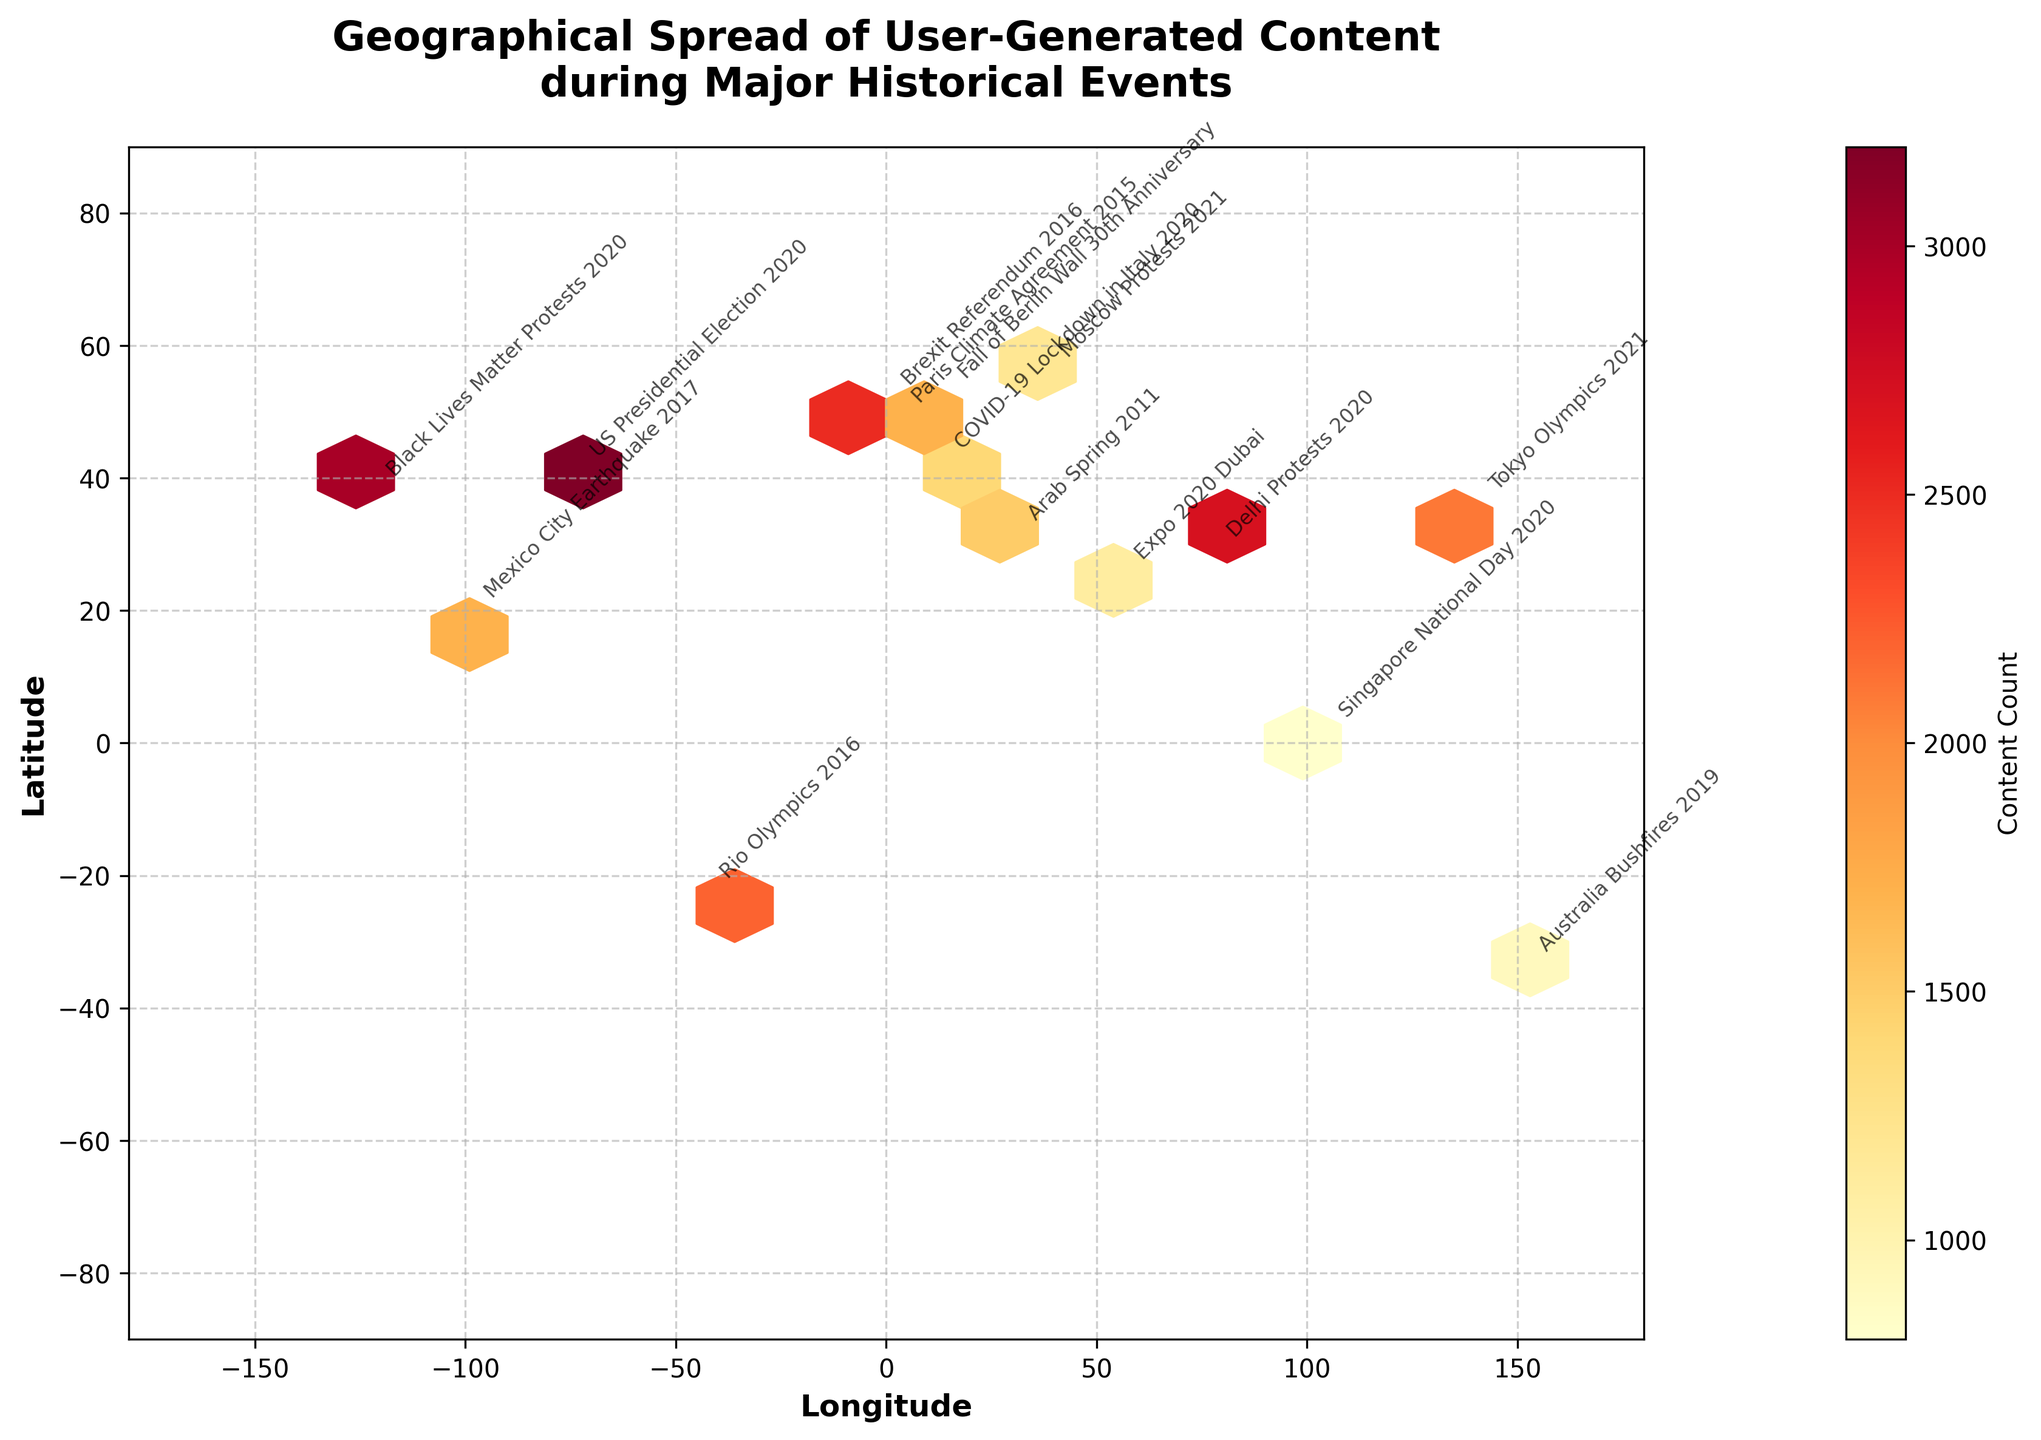What is the title of the plot? The title can be found at the top of the plot. The title is "Geographical Spread of User-Generated Content during Major Historical Events".
Answer: "Geographical Spread of User-Generated Content during Major Historical Events" How many hexagons/groups are there along the x-axis (Longitude)? The hexagons represent the geographical spread, and the extent of the x-axis is from -180 to 180 degrees, divided by the grid size of 20. Thus, there are approximately (180 - (-180)) / 20 = 18 hexagons.
Answer: Approximately 18 Which events are located near longitude 40? By locating the longitude axis and scanning around the 40-degree mark, it's observed that there are no events at longitude 40. The closest event would depend on the annotated points.
Answer: None directly at 40 Which historical event generated the highest amount of user-generated content? The highest content count is shown through color intensity in the hexbin plot. The event with the darkest hexagon and the most significant annotation would indicate the highest count. "US Presidential Election 2020" is the event with the highest count of 3200.
Answer: US Presidential Election 2020 What is the difference in content count between the "Tokyo Olympics 2021" and "Paris Climate Agreement 2015"? Tokyo Olympics 2021 corresponds to 2100 content counts while Paris Climate Agreement 2015 has 1800 content counts. The difference can be calculated as 2100 - 1800 = 300.
Answer: 300 Which event has a higher content count: "Brexit Referendum 2016" or "Black Lives Matter Protests 2020"? By comparing the annotations in the plot, "Black Lives Matter Protests 2020" has a content count of 3000, whereas "Brexit Referendum 2016" has 2500. So, the former has a higher count.
Answer: Black Lives Matter Protests 2020 What is the latitude and longitude range covered by the hexbin plot? The extent of the plot is given in the x-axis and y-axis labels, which range from -180 to 180 degrees in longitude and -90 to 90 degrees in latitude.
Answer: Longitude: -180 to 180, Latitude: -90 to 90 Which event has the lowest content count, and what is that count? The event with the lightest shade in the hexbin plot indicates the lowest content count. "Singapore National Day 2020" has the lowest count of 800.
Answer: Singapore National Day 2020, 800 Between "Australia Bushfires 2019" and "Mexico City Earthquake 2017", which event has a lower content count? By identifying the annotations, "Australia Bushfires 2019" has a content count of 900, while "Mexico City Earthquake 2017" has 1700. Thus, the Australia Bushfires 2019 has a lower count.
Answer: Australia Bushfires 2019 